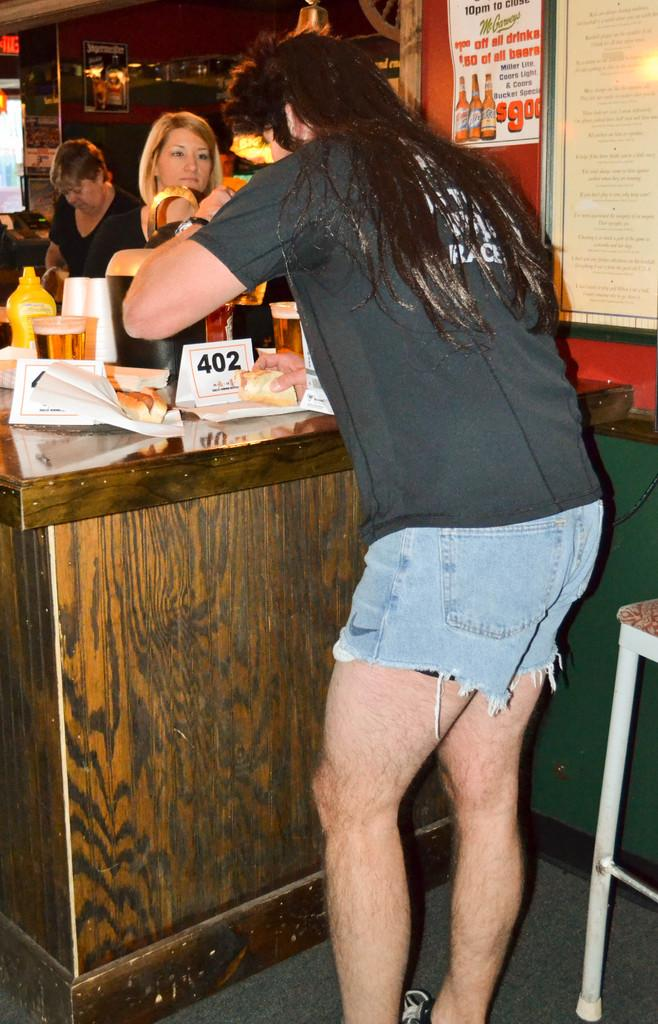What is the main subject of the image? There is a person standing in the image. Are there any other people visible in the image? Yes, there are two lady persons standing in the background of the image. What are the lady persons doing in the image? The lady persons are standing behind a wooden block. What type of neck can be seen on the deer in the image? There is no deer present in the image, so it is not possible to determine the type of neck. 